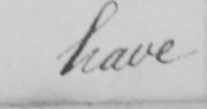What does this handwritten line say? have 